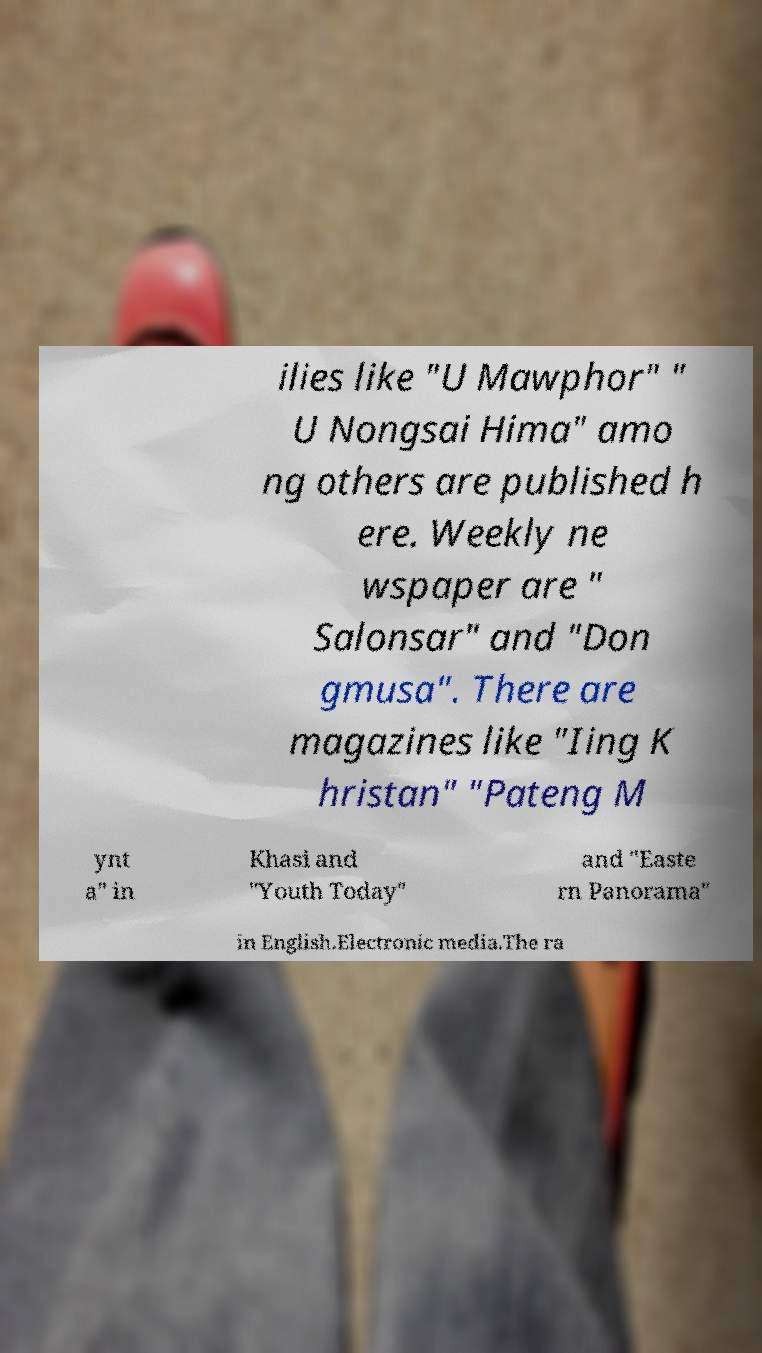I need the written content from this picture converted into text. Can you do that? ilies like "U Mawphor" " U Nongsai Hima" amo ng others are published h ere. Weekly ne wspaper are " Salonsar" and "Don gmusa". There are magazines like "Iing K hristan" "Pateng M ynt a" in Khasi and "Youth Today" and "Easte rn Panorama" in English.Electronic media.The ra 